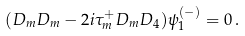<formula> <loc_0><loc_0><loc_500><loc_500>( D _ { m } D _ { m } - 2 i \tau _ { m } ^ { + } D _ { m } D _ { 4 } ) \psi _ { 1 } ^ { ( - ) } = 0 \, .</formula> 